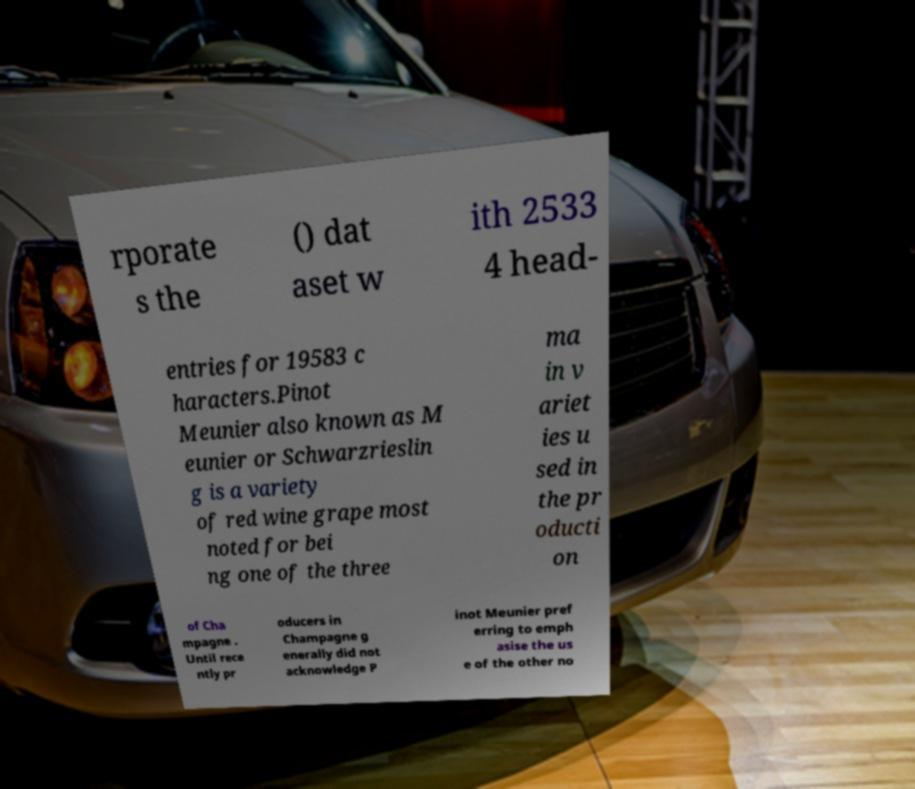Can you read and provide the text displayed in the image?This photo seems to have some interesting text. Can you extract and type it out for me? rporate s the () dat aset w ith 2533 4 head- entries for 19583 c haracters.Pinot Meunier also known as M eunier or Schwarzrieslin g is a variety of red wine grape most noted for bei ng one of the three ma in v ariet ies u sed in the pr oducti on of Cha mpagne . Until rece ntly pr oducers in Champagne g enerally did not acknowledge P inot Meunier pref erring to emph asise the us e of the other no 